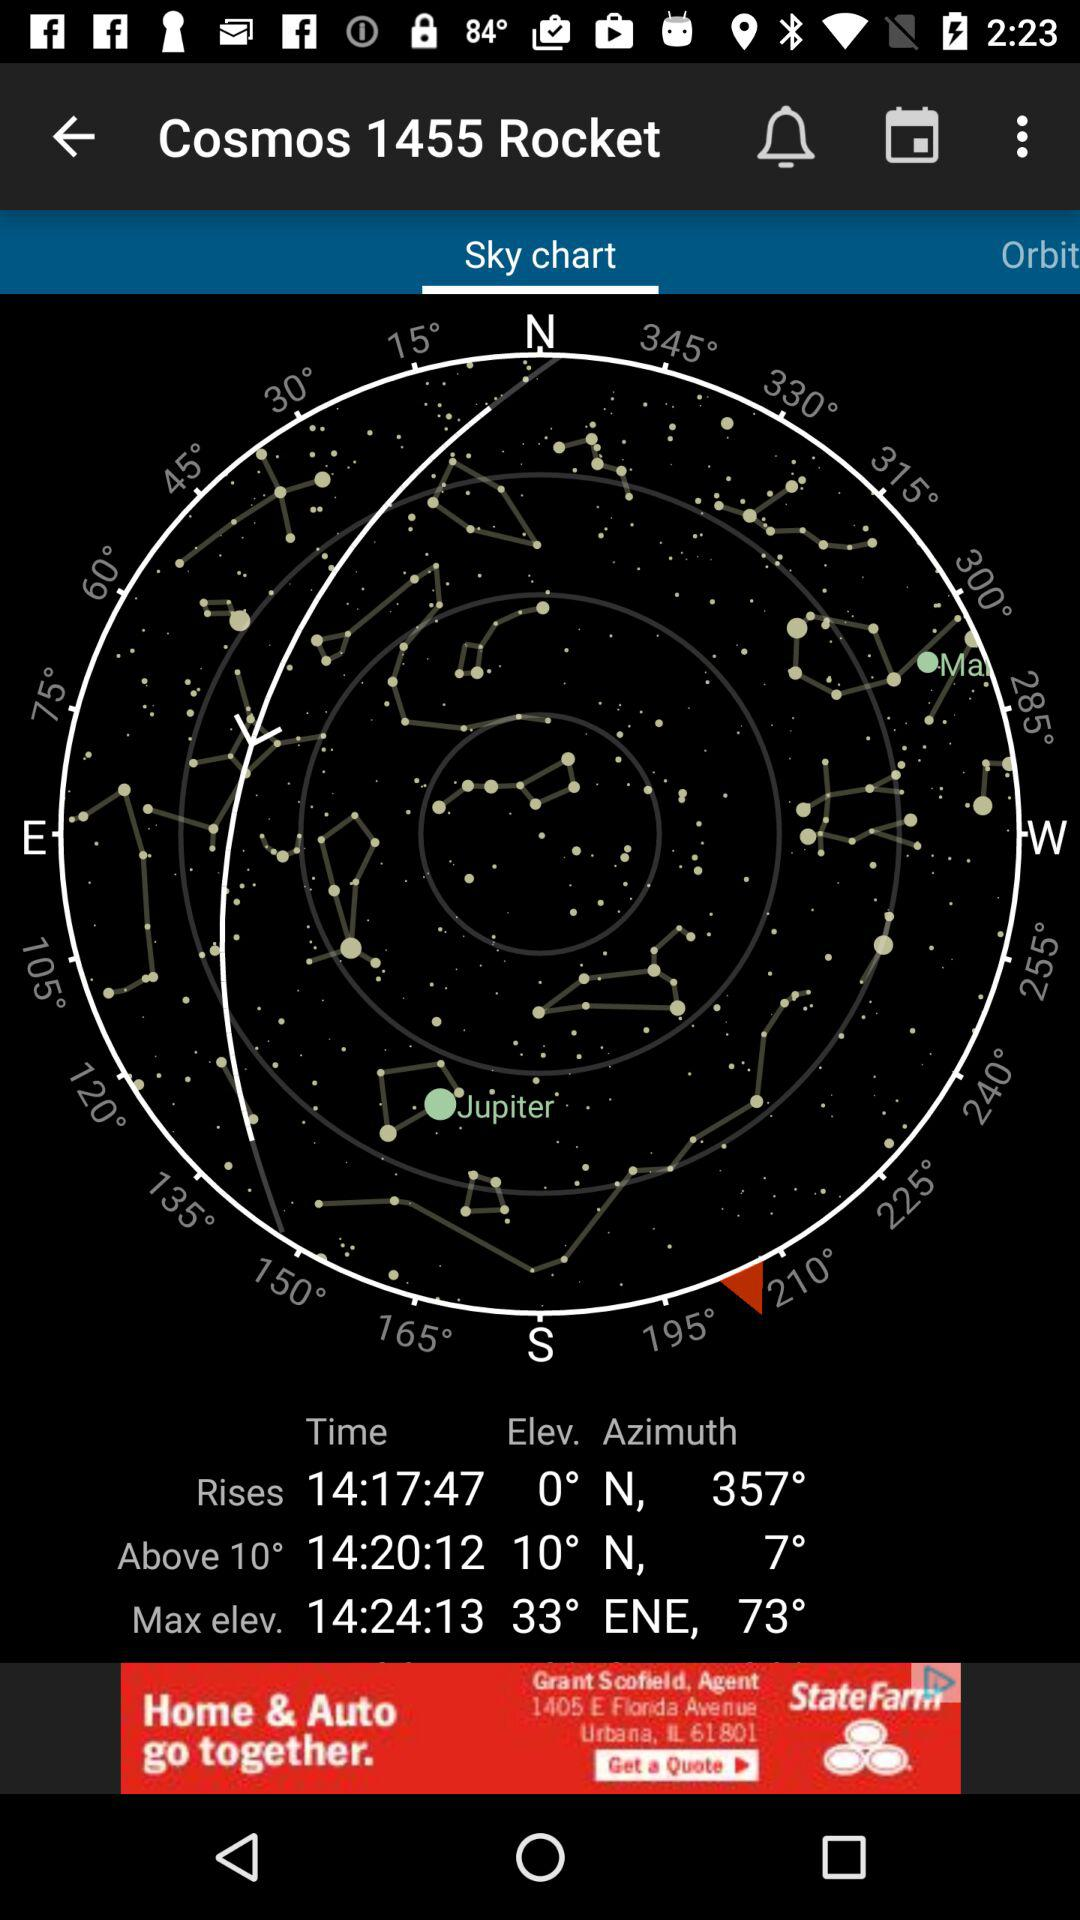What is the maximum elevation of the rocket?
Answer the question using a single word or phrase. 73° 